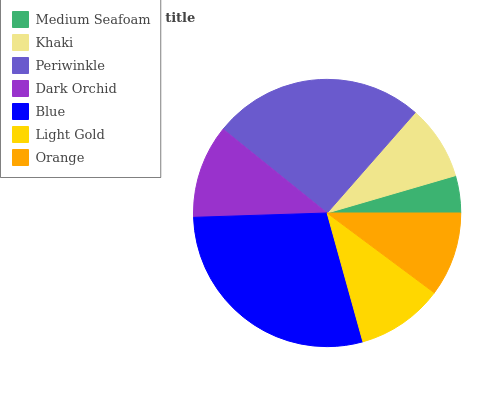Is Medium Seafoam the minimum?
Answer yes or no. Yes. Is Blue the maximum?
Answer yes or no. Yes. Is Khaki the minimum?
Answer yes or no. No. Is Khaki the maximum?
Answer yes or no. No. Is Khaki greater than Medium Seafoam?
Answer yes or no. Yes. Is Medium Seafoam less than Khaki?
Answer yes or no. Yes. Is Medium Seafoam greater than Khaki?
Answer yes or no. No. Is Khaki less than Medium Seafoam?
Answer yes or no. No. Is Light Gold the high median?
Answer yes or no. Yes. Is Light Gold the low median?
Answer yes or no. Yes. Is Medium Seafoam the high median?
Answer yes or no. No. Is Dark Orchid the low median?
Answer yes or no. No. 